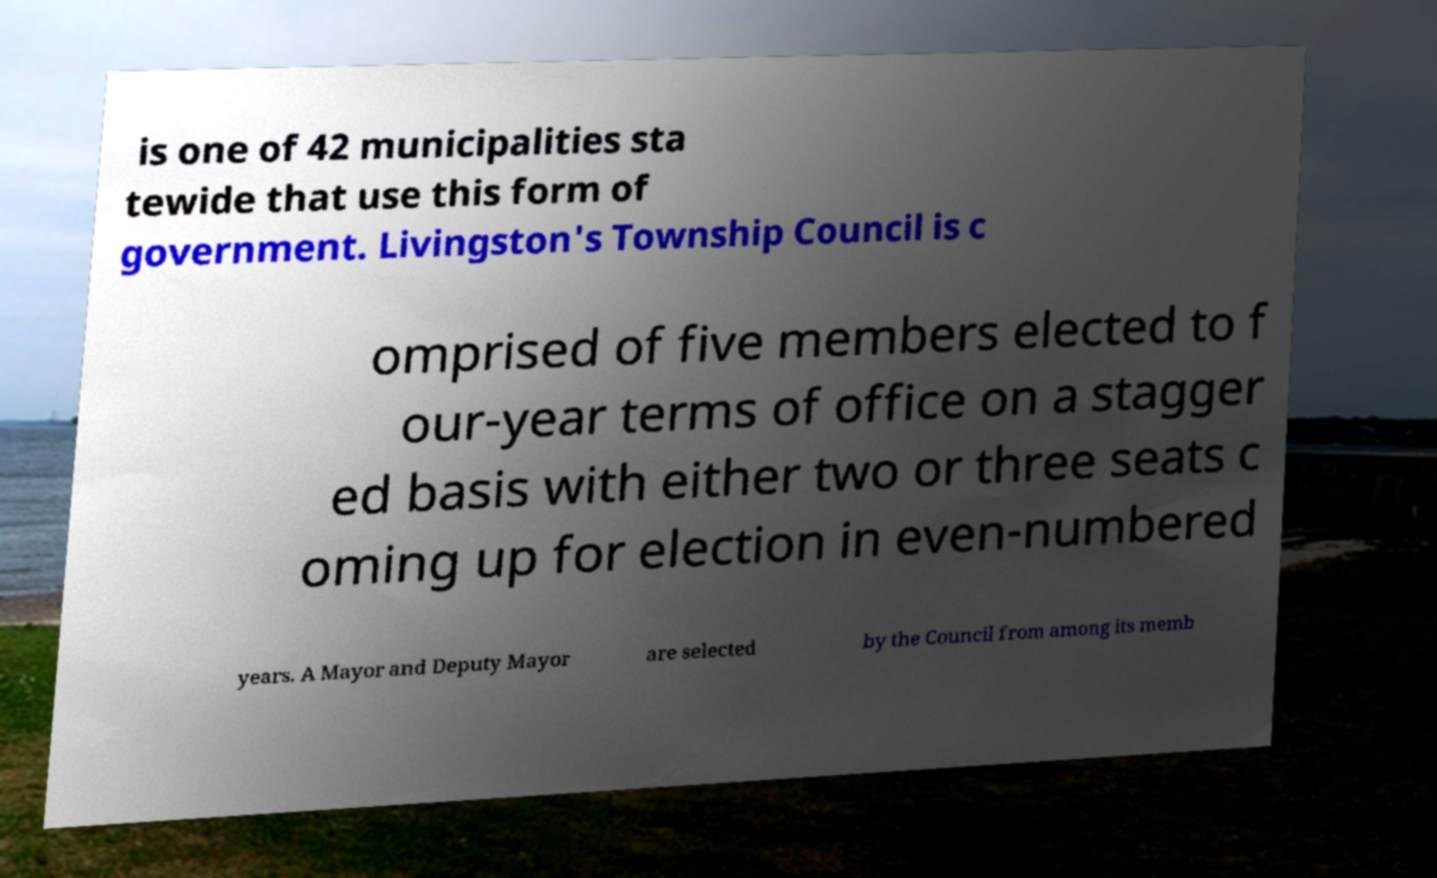For documentation purposes, I need the text within this image transcribed. Could you provide that? is one of 42 municipalities sta tewide that use this form of government. Livingston's Township Council is c omprised of five members elected to f our-year terms of office on a stagger ed basis with either two or three seats c oming up for election in even-numbered years. A Mayor and Deputy Mayor are selected by the Council from among its memb 